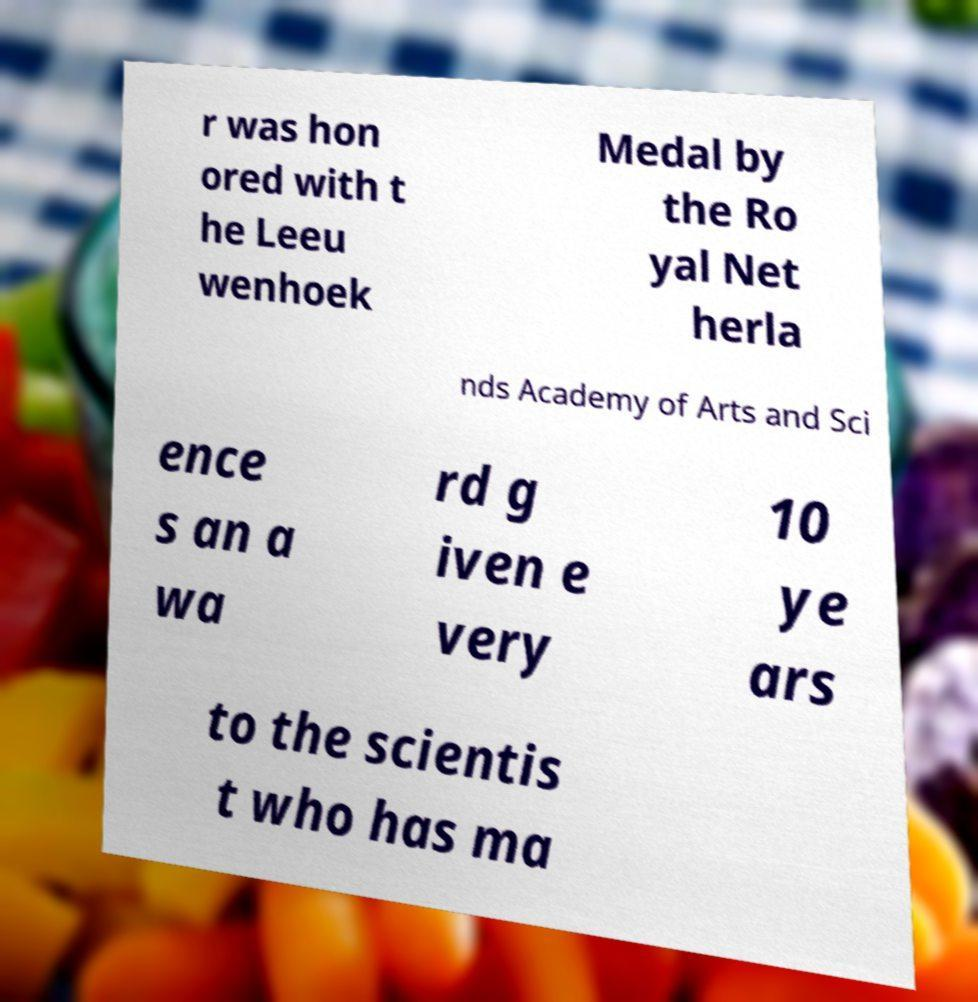Please read and relay the text visible in this image. What does it say? r was hon ored with t he Leeu wenhoek Medal by the Ro yal Net herla nds Academy of Arts and Sci ence s an a wa rd g iven e very 10 ye ars to the scientis t who has ma 